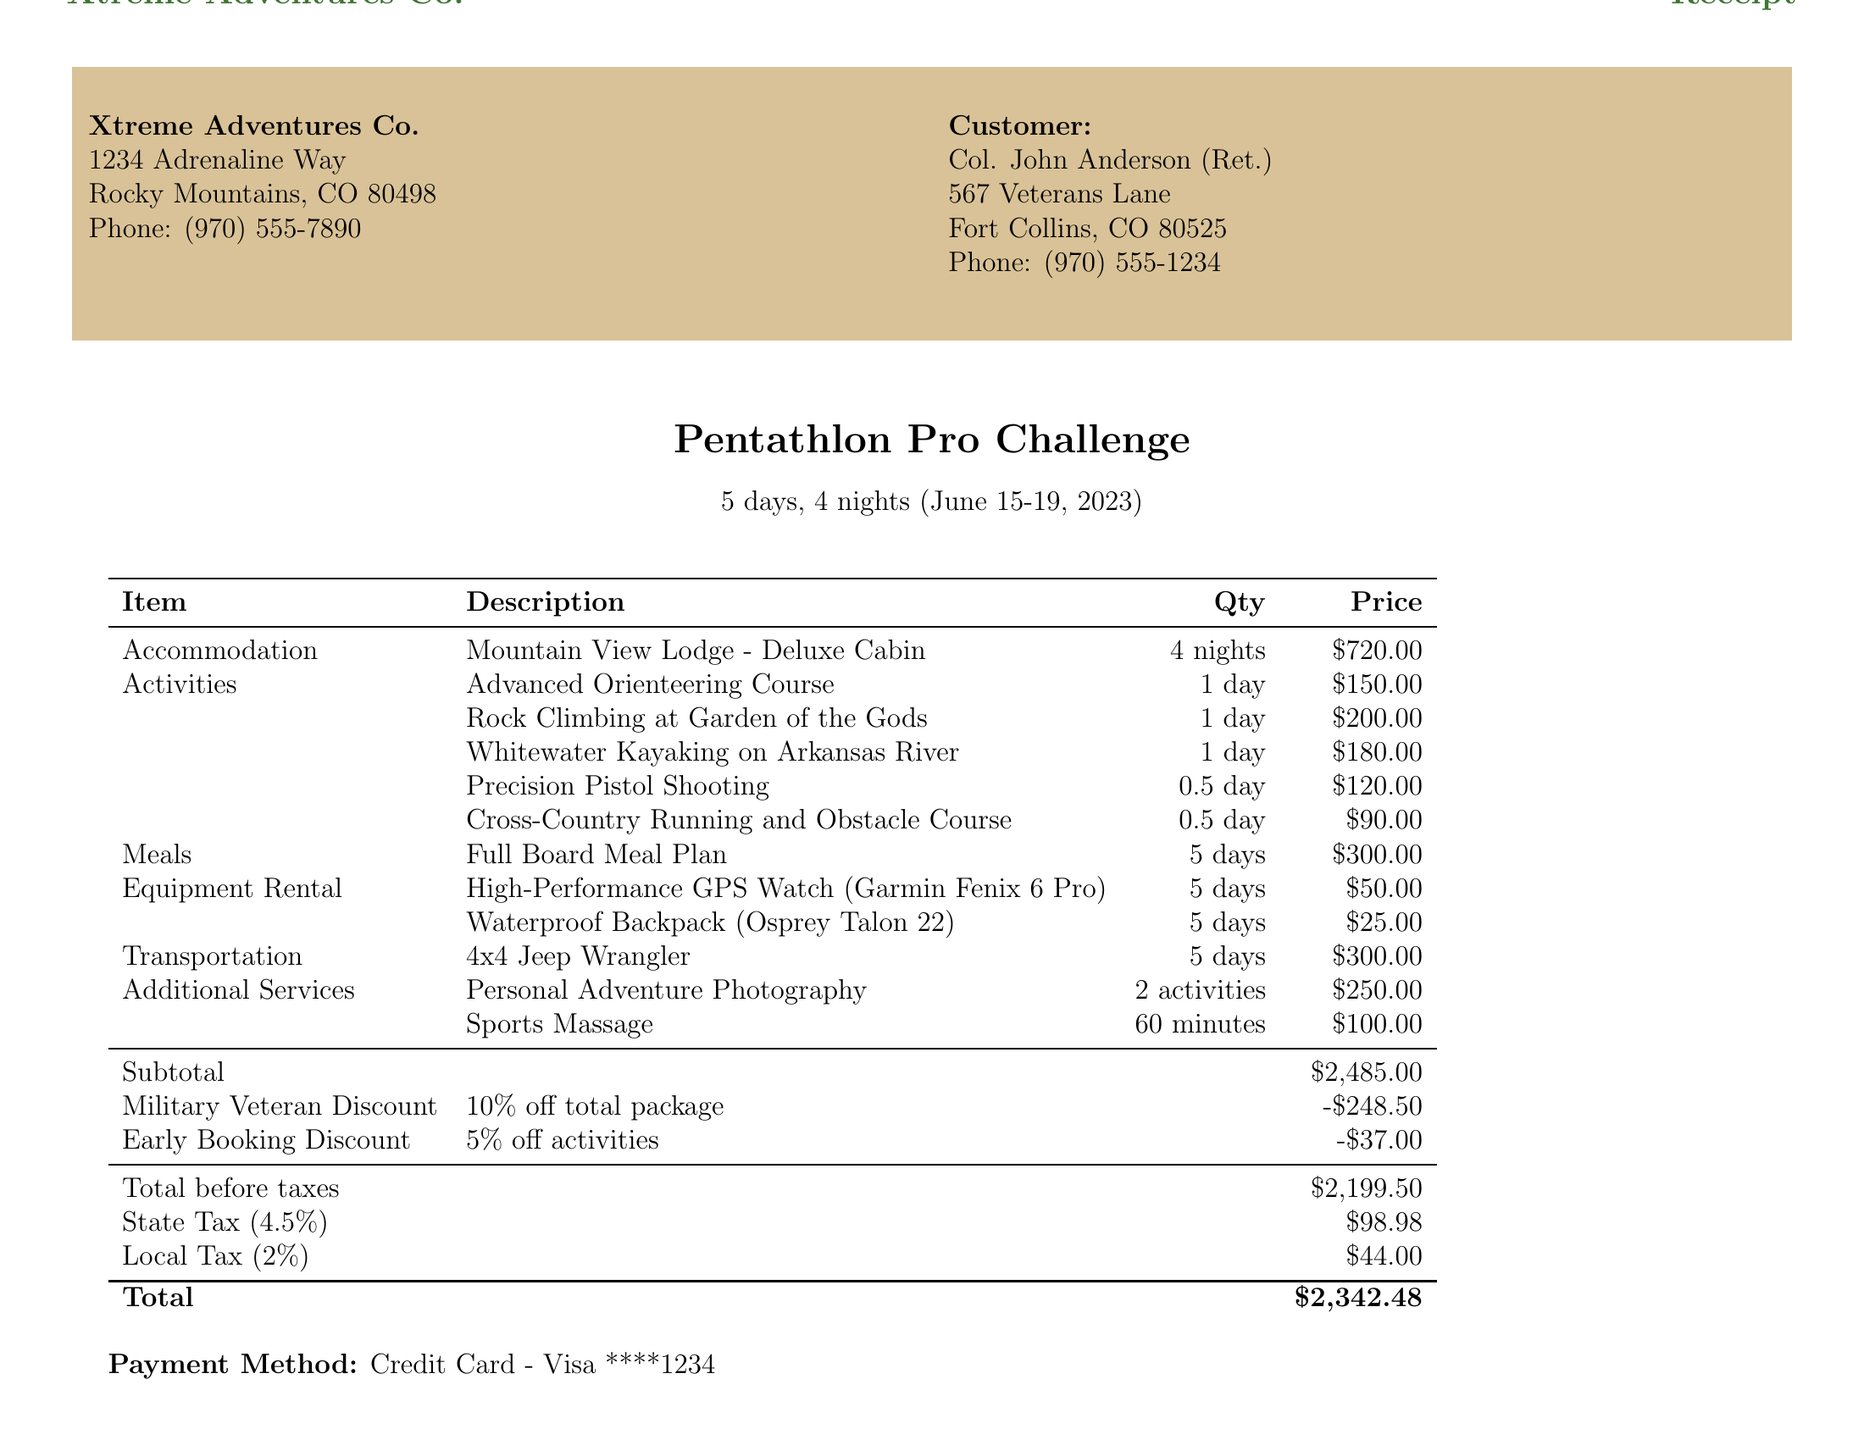what is the name of the package? The package name is specified clearly in the receipt as "Pentathlon Pro Challenge."
Answer: Pentathlon Pro Challenge how many days is the package duration? The duration of the package is indicated and it is "5 days, 4 nights."
Answer: 5 days, 4 nights what is the total price after discounts? The total price after applying all discounts is calculated in the document and is stated as "$2,342.48."
Answer: $2,342.48 what is the location for the Precision Pistol Shooting activity? The receipt mentions "Colorado Clays Shooting Park" as the location for the activity.
Answer: Colorado Clays Shooting Park how much is charged for the Full Board Meal Plan per day? The price for the Full Board Meal Plan is specified as "$60" per day.
Answer: $60 what is the name of the lodge for accommodations? The accommodations section of the receipt specifies "Mountain View Lodge."
Answer: Mountain View Lodge how many activities are included in the package? By counting the activities listed in the document, there are five activities included.
Answer: 5 what is the military discount percentage? The document clearly states a 10% discount for military veterans.
Answer: 10% what type of vehicle is included in the transportation? The transportation section of the document indicates a "4x4 Jeep Wrangler."
Answer: 4x4 Jeep Wrangler what policy is stated regarding cancellations? The cancellation policy details in the document specify the conditions for refunds based on cancellation timing.
Answer: Full refund if cancelled 30 days before the start date 